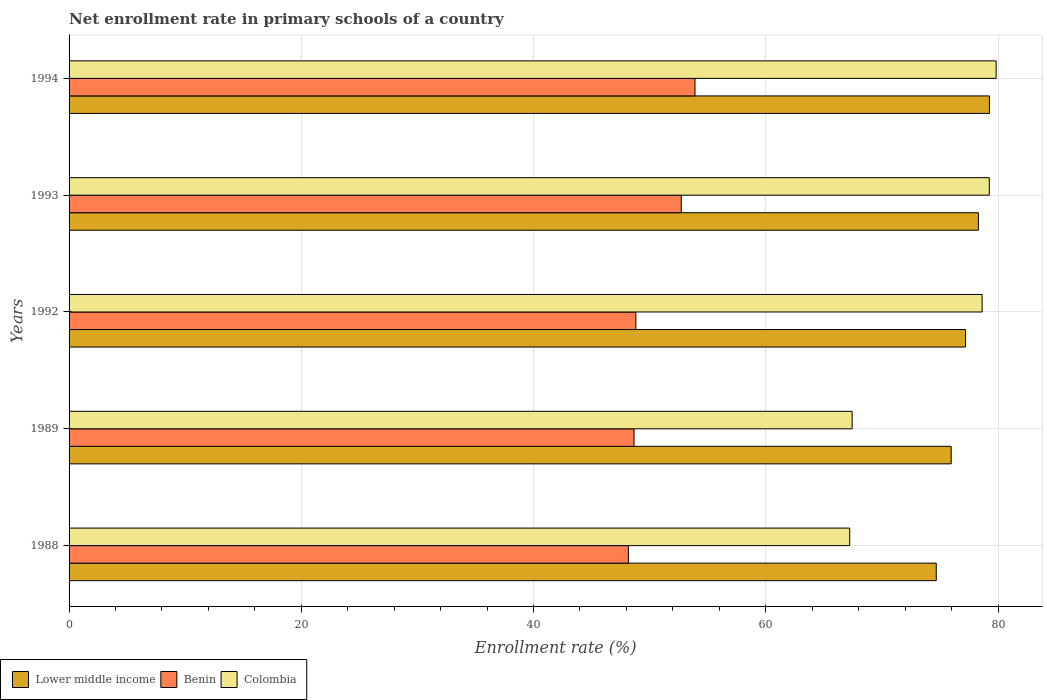How many different coloured bars are there?
Ensure brevity in your answer.  3. How many groups of bars are there?
Offer a very short reply. 5. Are the number of bars per tick equal to the number of legend labels?
Your answer should be very brief. Yes. Are the number of bars on each tick of the Y-axis equal?
Provide a short and direct response. Yes. In how many cases, is the number of bars for a given year not equal to the number of legend labels?
Provide a succinct answer. 0. What is the enrollment rate in primary schools in Lower middle income in 1993?
Your response must be concise. 78.31. Across all years, what is the maximum enrollment rate in primary schools in Benin?
Your answer should be compact. 53.9. Across all years, what is the minimum enrollment rate in primary schools in Benin?
Provide a short and direct response. 48.17. In which year was the enrollment rate in primary schools in Colombia maximum?
Your answer should be compact. 1994. In which year was the enrollment rate in primary schools in Colombia minimum?
Keep it short and to the point. 1988. What is the total enrollment rate in primary schools in Lower middle income in the graph?
Provide a short and direct response. 385.43. What is the difference between the enrollment rate in primary schools in Benin in 1992 and that in 1994?
Keep it short and to the point. -5.09. What is the difference between the enrollment rate in primary schools in Lower middle income in 1993 and the enrollment rate in primary schools in Benin in 1988?
Provide a short and direct response. 30.14. What is the average enrollment rate in primary schools in Benin per year?
Provide a short and direct response. 50.45. In the year 1989, what is the difference between the enrollment rate in primary schools in Benin and enrollment rate in primary schools in Lower middle income?
Give a very brief answer. -27.31. What is the ratio of the enrollment rate in primary schools in Colombia in 1992 to that in 1994?
Your answer should be compact. 0.98. Is the difference between the enrollment rate in primary schools in Benin in 1989 and 1994 greater than the difference between the enrollment rate in primary schools in Lower middle income in 1989 and 1994?
Offer a very short reply. No. What is the difference between the highest and the second highest enrollment rate in primary schools in Colombia?
Offer a terse response. 0.59. What is the difference between the highest and the lowest enrollment rate in primary schools in Colombia?
Provide a succinct answer. 12.61. What does the 3rd bar from the top in 1993 represents?
Your answer should be compact. Lower middle income. What does the 2nd bar from the bottom in 1992 represents?
Keep it short and to the point. Benin. How many years are there in the graph?
Your response must be concise. 5. What is the difference between two consecutive major ticks on the X-axis?
Your answer should be compact. 20. Are the values on the major ticks of X-axis written in scientific E-notation?
Keep it short and to the point. No. Does the graph contain any zero values?
Give a very brief answer. No. How are the legend labels stacked?
Make the answer very short. Horizontal. What is the title of the graph?
Offer a very short reply. Net enrollment rate in primary schools of a country. Does "Honduras" appear as one of the legend labels in the graph?
Provide a succinct answer. No. What is the label or title of the X-axis?
Keep it short and to the point. Enrollment rate (%). What is the label or title of the Y-axis?
Give a very brief answer. Years. What is the Enrollment rate (%) of Lower middle income in 1988?
Your answer should be compact. 74.68. What is the Enrollment rate (%) of Benin in 1988?
Provide a short and direct response. 48.17. What is the Enrollment rate (%) of Colombia in 1988?
Your answer should be compact. 67.23. What is the Enrollment rate (%) in Lower middle income in 1989?
Make the answer very short. 75.97. What is the Enrollment rate (%) in Benin in 1989?
Offer a terse response. 48.65. What is the Enrollment rate (%) in Colombia in 1989?
Your answer should be compact. 67.44. What is the Enrollment rate (%) of Lower middle income in 1992?
Make the answer very short. 77.2. What is the Enrollment rate (%) of Benin in 1992?
Your answer should be very brief. 48.81. What is the Enrollment rate (%) of Colombia in 1992?
Offer a terse response. 78.63. What is the Enrollment rate (%) in Lower middle income in 1993?
Provide a succinct answer. 78.31. What is the Enrollment rate (%) in Benin in 1993?
Make the answer very short. 52.72. What is the Enrollment rate (%) of Colombia in 1993?
Give a very brief answer. 79.25. What is the Enrollment rate (%) in Lower middle income in 1994?
Your answer should be compact. 79.26. What is the Enrollment rate (%) in Benin in 1994?
Your answer should be very brief. 53.9. What is the Enrollment rate (%) of Colombia in 1994?
Your answer should be very brief. 79.84. Across all years, what is the maximum Enrollment rate (%) of Lower middle income?
Keep it short and to the point. 79.26. Across all years, what is the maximum Enrollment rate (%) in Benin?
Make the answer very short. 53.9. Across all years, what is the maximum Enrollment rate (%) in Colombia?
Keep it short and to the point. 79.84. Across all years, what is the minimum Enrollment rate (%) in Lower middle income?
Ensure brevity in your answer.  74.68. Across all years, what is the minimum Enrollment rate (%) in Benin?
Ensure brevity in your answer.  48.17. Across all years, what is the minimum Enrollment rate (%) in Colombia?
Give a very brief answer. 67.23. What is the total Enrollment rate (%) of Lower middle income in the graph?
Your answer should be compact. 385.43. What is the total Enrollment rate (%) in Benin in the graph?
Your response must be concise. 252.26. What is the total Enrollment rate (%) of Colombia in the graph?
Ensure brevity in your answer.  372.39. What is the difference between the Enrollment rate (%) in Lower middle income in 1988 and that in 1989?
Your response must be concise. -1.29. What is the difference between the Enrollment rate (%) of Benin in 1988 and that in 1989?
Keep it short and to the point. -0.49. What is the difference between the Enrollment rate (%) in Colombia in 1988 and that in 1989?
Offer a very short reply. -0.21. What is the difference between the Enrollment rate (%) of Lower middle income in 1988 and that in 1992?
Give a very brief answer. -2.52. What is the difference between the Enrollment rate (%) in Benin in 1988 and that in 1992?
Give a very brief answer. -0.64. What is the difference between the Enrollment rate (%) in Colombia in 1988 and that in 1992?
Your response must be concise. -11.4. What is the difference between the Enrollment rate (%) of Lower middle income in 1988 and that in 1993?
Your answer should be very brief. -3.63. What is the difference between the Enrollment rate (%) in Benin in 1988 and that in 1993?
Make the answer very short. -4.55. What is the difference between the Enrollment rate (%) in Colombia in 1988 and that in 1993?
Your answer should be compact. -12.02. What is the difference between the Enrollment rate (%) of Lower middle income in 1988 and that in 1994?
Offer a terse response. -4.58. What is the difference between the Enrollment rate (%) of Benin in 1988 and that in 1994?
Offer a terse response. -5.74. What is the difference between the Enrollment rate (%) in Colombia in 1988 and that in 1994?
Keep it short and to the point. -12.61. What is the difference between the Enrollment rate (%) in Lower middle income in 1989 and that in 1992?
Keep it short and to the point. -1.24. What is the difference between the Enrollment rate (%) of Benin in 1989 and that in 1992?
Keep it short and to the point. -0.16. What is the difference between the Enrollment rate (%) of Colombia in 1989 and that in 1992?
Offer a very short reply. -11.19. What is the difference between the Enrollment rate (%) in Lower middle income in 1989 and that in 1993?
Ensure brevity in your answer.  -2.34. What is the difference between the Enrollment rate (%) of Benin in 1989 and that in 1993?
Give a very brief answer. -4.06. What is the difference between the Enrollment rate (%) in Colombia in 1989 and that in 1993?
Give a very brief answer. -11.81. What is the difference between the Enrollment rate (%) in Lower middle income in 1989 and that in 1994?
Give a very brief answer. -3.29. What is the difference between the Enrollment rate (%) of Benin in 1989 and that in 1994?
Make the answer very short. -5.25. What is the difference between the Enrollment rate (%) of Colombia in 1989 and that in 1994?
Provide a succinct answer. -12.4. What is the difference between the Enrollment rate (%) in Lower middle income in 1992 and that in 1993?
Give a very brief answer. -1.11. What is the difference between the Enrollment rate (%) in Benin in 1992 and that in 1993?
Ensure brevity in your answer.  -3.91. What is the difference between the Enrollment rate (%) in Colombia in 1992 and that in 1993?
Offer a terse response. -0.61. What is the difference between the Enrollment rate (%) of Lower middle income in 1992 and that in 1994?
Provide a short and direct response. -2.06. What is the difference between the Enrollment rate (%) of Benin in 1992 and that in 1994?
Make the answer very short. -5.09. What is the difference between the Enrollment rate (%) of Colombia in 1992 and that in 1994?
Provide a short and direct response. -1.21. What is the difference between the Enrollment rate (%) of Lower middle income in 1993 and that in 1994?
Provide a short and direct response. -0.95. What is the difference between the Enrollment rate (%) in Benin in 1993 and that in 1994?
Offer a terse response. -1.18. What is the difference between the Enrollment rate (%) in Colombia in 1993 and that in 1994?
Your answer should be compact. -0.59. What is the difference between the Enrollment rate (%) of Lower middle income in 1988 and the Enrollment rate (%) of Benin in 1989?
Your response must be concise. 26.03. What is the difference between the Enrollment rate (%) in Lower middle income in 1988 and the Enrollment rate (%) in Colombia in 1989?
Offer a terse response. 7.24. What is the difference between the Enrollment rate (%) in Benin in 1988 and the Enrollment rate (%) in Colombia in 1989?
Make the answer very short. -19.27. What is the difference between the Enrollment rate (%) in Lower middle income in 1988 and the Enrollment rate (%) in Benin in 1992?
Your response must be concise. 25.87. What is the difference between the Enrollment rate (%) of Lower middle income in 1988 and the Enrollment rate (%) of Colombia in 1992?
Your answer should be compact. -3.95. What is the difference between the Enrollment rate (%) of Benin in 1988 and the Enrollment rate (%) of Colombia in 1992?
Offer a terse response. -30.46. What is the difference between the Enrollment rate (%) in Lower middle income in 1988 and the Enrollment rate (%) in Benin in 1993?
Provide a short and direct response. 21.96. What is the difference between the Enrollment rate (%) in Lower middle income in 1988 and the Enrollment rate (%) in Colombia in 1993?
Your answer should be compact. -4.56. What is the difference between the Enrollment rate (%) of Benin in 1988 and the Enrollment rate (%) of Colombia in 1993?
Provide a succinct answer. -31.08. What is the difference between the Enrollment rate (%) of Lower middle income in 1988 and the Enrollment rate (%) of Benin in 1994?
Offer a very short reply. 20.78. What is the difference between the Enrollment rate (%) in Lower middle income in 1988 and the Enrollment rate (%) in Colombia in 1994?
Keep it short and to the point. -5.16. What is the difference between the Enrollment rate (%) in Benin in 1988 and the Enrollment rate (%) in Colombia in 1994?
Offer a very short reply. -31.67. What is the difference between the Enrollment rate (%) of Lower middle income in 1989 and the Enrollment rate (%) of Benin in 1992?
Your response must be concise. 27.16. What is the difference between the Enrollment rate (%) in Lower middle income in 1989 and the Enrollment rate (%) in Colombia in 1992?
Ensure brevity in your answer.  -2.66. What is the difference between the Enrollment rate (%) in Benin in 1989 and the Enrollment rate (%) in Colombia in 1992?
Provide a succinct answer. -29.98. What is the difference between the Enrollment rate (%) of Lower middle income in 1989 and the Enrollment rate (%) of Benin in 1993?
Provide a succinct answer. 23.25. What is the difference between the Enrollment rate (%) of Lower middle income in 1989 and the Enrollment rate (%) of Colombia in 1993?
Your answer should be compact. -3.28. What is the difference between the Enrollment rate (%) of Benin in 1989 and the Enrollment rate (%) of Colombia in 1993?
Your answer should be compact. -30.59. What is the difference between the Enrollment rate (%) of Lower middle income in 1989 and the Enrollment rate (%) of Benin in 1994?
Your answer should be compact. 22.06. What is the difference between the Enrollment rate (%) of Lower middle income in 1989 and the Enrollment rate (%) of Colombia in 1994?
Offer a terse response. -3.87. What is the difference between the Enrollment rate (%) of Benin in 1989 and the Enrollment rate (%) of Colombia in 1994?
Keep it short and to the point. -31.18. What is the difference between the Enrollment rate (%) in Lower middle income in 1992 and the Enrollment rate (%) in Benin in 1993?
Keep it short and to the point. 24.48. What is the difference between the Enrollment rate (%) in Lower middle income in 1992 and the Enrollment rate (%) in Colombia in 1993?
Provide a succinct answer. -2.04. What is the difference between the Enrollment rate (%) in Benin in 1992 and the Enrollment rate (%) in Colombia in 1993?
Your answer should be compact. -30.43. What is the difference between the Enrollment rate (%) in Lower middle income in 1992 and the Enrollment rate (%) in Benin in 1994?
Provide a succinct answer. 23.3. What is the difference between the Enrollment rate (%) in Lower middle income in 1992 and the Enrollment rate (%) in Colombia in 1994?
Provide a succinct answer. -2.64. What is the difference between the Enrollment rate (%) in Benin in 1992 and the Enrollment rate (%) in Colombia in 1994?
Your answer should be compact. -31.03. What is the difference between the Enrollment rate (%) in Lower middle income in 1993 and the Enrollment rate (%) in Benin in 1994?
Offer a very short reply. 24.41. What is the difference between the Enrollment rate (%) in Lower middle income in 1993 and the Enrollment rate (%) in Colombia in 1994?
Your answer should be very brief. -1.53. What is the difference between the Enrollment rate (%) of Benin in 1993 and the Enrollment rate (%) of Colombia in 1994?
Provide a short and direct response. -27.12. What is the average Enrollment rate (%) of Lower middle income per year?
Your response must be concise. 77.09. What is the average Enrollment rate (%) in Benin per year?
Ensure brevity in your answer.  50.45. What is the average Enrollment rate (%) of Colombia per year?
Your answer should be compact. 74.48. In the year 1988, what is the difference between the Enrollment rate (%) of Lower middle income and Enrollment rate (%) of Benin?
Provide a short and direct response. 26.51. In the year 1988, what is the difference between the Enrollment rate (%) in Lower middle income and Enrollment rate (%) in Colombia?
Your answer should be very brief. 7.45. In the year 1988, what is the difference between the Enrollment rate (%) in Benin and Enrollment rate (%) in Colombia?
Your response must be concise. -19.06. In the year 1989, what is the difference between the Enrollment rate (%) in Lower middle income and Enrollment rate (%) in Benin?
Your answer should be compact. 27.31. In the year 1989, what is the difference between the Enrollment rate (%) in Lower middle income and Enrollment rate (%) in Colombia?
Ensure brevity in your answer.  8.53. In the year 1989, what is the difference between the Enrollment rate (%) in Benin and Enrollment rate (%) in Colombia?
Make the answer very short. -18.78. In the year 1992, what is the difference between the Enrollment rate (%) of Lower middle income and Enrollment rate (%) of Benin?
Offer a terse response. 28.39. In the year 1992, what is the difference between the Enrollment rate (%) of Lower middle income and Enrollment rate (%) of Colombia?
Provide a succinct answer. -1.43. In the year 1992, what is the difference between the Enrollment rate (%) of Benin and Enrollment rate (%) of Colombia?
Provide a succinct answer. -29.82. In the year 1993, what is the difference between the Enrollment rate (%) in Lower middle income and Enrollment rate (%) in Benin?
Provide a short and direct response. 25.59. In the year 1993, what is the difference between the Enrollment rate (%) in Lower middle income and Enrollment rate (%) in Colombia?
Offer a very short reply. -0.93. In the year 1993, what is the difference between the Enrollment rate (%) in Benin and Enrollment rate (%) in Colombia?
Ensure brevity in your answer.  -26.53. In the year 1994, what is the difference between the Enrollment rate (%) of Lower middle income and Enrollment rate (%) of Benin?
Your answer should be compact. 25.36. In the year 1994, what is the difference between the Enrollment rate (%) of Lower middle income and Enrollment rate (%) of Colombia?
Offer a very short reply. -0.58. In the year 1994, what is the difference between the Enrollment rate (%) of Benin and Enrollment rate (%) of Colombia?
Keep it short and to the point. -25.93. What is the ratio of the Enrollment rate (%) of Lower middle income in 1988 to that in 1989?
Your answer should be very brief. 0.98. What is the ratio of the Enrollment rate (%) in Lower middle income in 1988 to that in 1992?
Keep it short and to the point. 0.97. What is the ratio of the Enrollment rate (%) in Benin in 1988 to that in 1992?
Keep it short and to the point. 0.99. What is the ratio of the Enrollment rate (%) of Colombia in 1988 to that in 1992?
Ensure brevity in your answer.  0.85. What is the ratio of the Enrollment rate (%) in Lower middle income in 1988 to that in 1993?
Make the answer very short. 0.95. What is the ratio of the Enrollment rate (%) in Benin in 1988 to that in 1993?
Give a very brief answer. 0.91. What is the ratio of the Enrollment rate (%) of Colombia in 1988 to that in 1993?
Ensure brevity in your answer.  0.85. What is the ratio of the Enrollment rate (%) of Lower middle income in 1988 to that in 1994?
Your answer should be very brief. 0.94. What is the ratio of the Enrollment rate (%) of Benin in 1988 to that in 1994?
Make the answer very short. 0.89. What is the ratio of the Enrollment rate (%) in Colombia in 1988 to that in 1994?
Offer a terse response. 0.84. What is the ratio of the Enrollment rate (%) in Colombia in 1989 to that in 1992?
Give a very brief answer. 0.86. What is the ratio of the Enrollment rate (%) of Lower middle income in 1989 to that in 1993?
Provide a short and direct response. 0.97. What is the ratio of the Enrollment rate (%) in Benin in 1989 to that in 1993?
Give a very brief answer. 0.92. What is the ratio of the Enrollment rate (%) of Colombia in 1989 to that in 1993?
Provide a succinct answer. 0.85. What is the ratio of the Enrollment rate (%) of Lower middle income in 1989 to that in 1994?
Ensure brevity in your answer.  0.96. What is the ratio of the Enrollment rate (%) in Benin in 1989 to that in 1994?
Your answer should be compact. 0.9. What is the ratio of the Enrollment rate (%) of Colombia in 1989 to that in 1994?
Provide a short and direct response. 0.84. What is the ratio of the Enrollment rate (%) of Lower middle income in 1992 to that in 1993?
Keep it short and to the point. 0.99. What is the ratio of the Enrollment rate (%) in Benin in 1992 to that in 1993?
Your answer should be compact. 0.93. What is the ratio of the Enrollment rate (%) of Benin in 1992 to that in 1994?
Your answer should be compact. 0.91. What is the ratio of the Enrollment rate (%) in Colombia in 1992 to that in 1994?
Your response must be concise. 0.98. What is the ratio of the Enrollment rate (%) in Benin in 1993 to that in 1994?
Provide a succinct answer. 0.98. What is the ratio of the Enrollment rate (%) in Colombia in 1993 to that in 1994?
Your answer should be very brief. 0.99. What is the difference between the highest and the second highest Enrollment rate (%) in Lower middle income?
Your answer should be compact. 0.95. What is the difference between the highest and the second highest Enrollment rate (%) in Benin?
Provide a short and direct response. 1.18. What is the difference between the highest and the second highest Enrollment rate (%) of Colombia?
Ensure brevity in your answer.  0.59. What is the difference between the highest and the lowest Enrollment rate (%) in Lower middle income?
Provide a short and direct response. 4.58. What is the difference between the highest and the lowest Enrollment rate (%) of Benin?
Your answer should be compact. 5.74. What is the difference between the highest and the lowest Enrollment rate (%) in Colombia?
Your response must be concise. 12.61. 